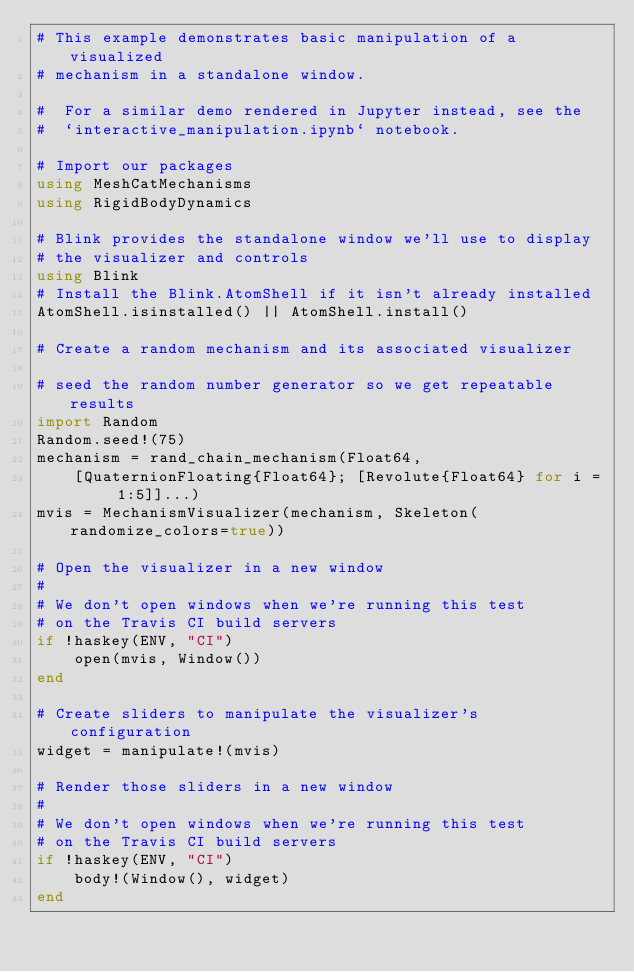Convert code to text. <code><loc_0><loc_0><loc_500><loc_500><_Julia_># This example demonstrates basic manipulation of a visualized
# mechanism in a standalone window.

#  For a similar demo rendered in Jupyter instead, see the
#  `interactive_manipulation.ipynb` notebook.

# Import our packages
using MeshCatMechanisms
using RigidBodyDynamics

# Blink provides the standalone window we'll use to display
# the visualizer and controls
using Blink
# Install the Blink.AtomShell if it isn't already installed
AtomShell.isinstalled() || AtomShell.install()

# Create a random mechanism and its associated visualizer

# seed the random number generator so we get repeatable results
import Random
Random.seed!(75)
mechanism = rand_chain_mechanism(Float64,
    [QuaternionFloating{Float64}; [Revolute{Float64} for i = 1:5]]...)
mvis = MechanismVisualizer(mechanism, Skeleton(randomize_colors=true))

# Open the visualizer in a new window
#
# We don't open windows when we're running this test
# on the Travis CI build servers
if !haskey(ENV, "CI")
    open(mvis, Window())
end

# Create sliders to manipulate the visualizer's configuration
widget = manipulate!(mvis)

# Render those sliders in a new window
#
# We don't open windows when we're running this test
# on the Travis CI build servers
if !haskey(ENV, "CI")
    body!(Window(), widget)
end
</code> 